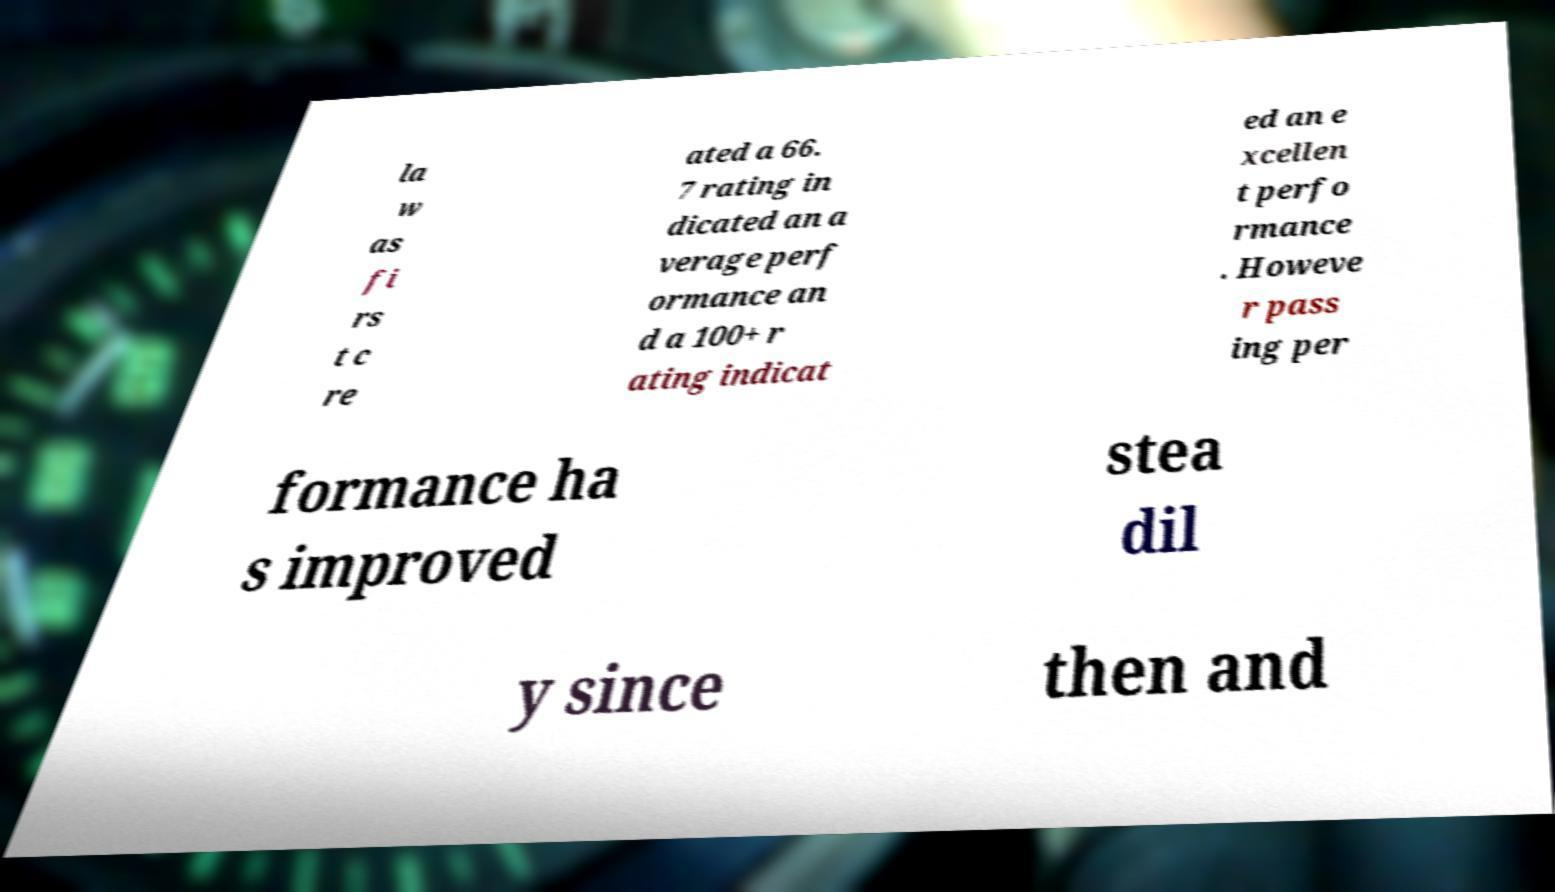What messages or text are displayed in this image? I need them in a readable, typed format. la w as fi rs t c re ated a 66. 7 rating in dicated an a verage perf ormance an d a 100+ r ating indicat ed an e xcellen t perfo rmance . Howeve r pass ing per formance ha s improved stea dil y since then and 